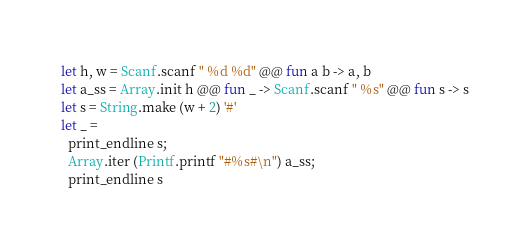Convert code to text. <code><loc_0><loc_0><loc_500><loc_500><_OCaml_>let h, w = Scanf.scanf " %d %d" @@ fun a b -> a, b
let a_ss = Array.init h @@ fun _ -> Scanf.scanf " %s" @@ fun s -> s
let s = String.make (w + 2) '#'
let _ =
  print_endline s;
  Array.iter (Printf.printf "#%s#\n") a_ss;
  print_endline s</code> 